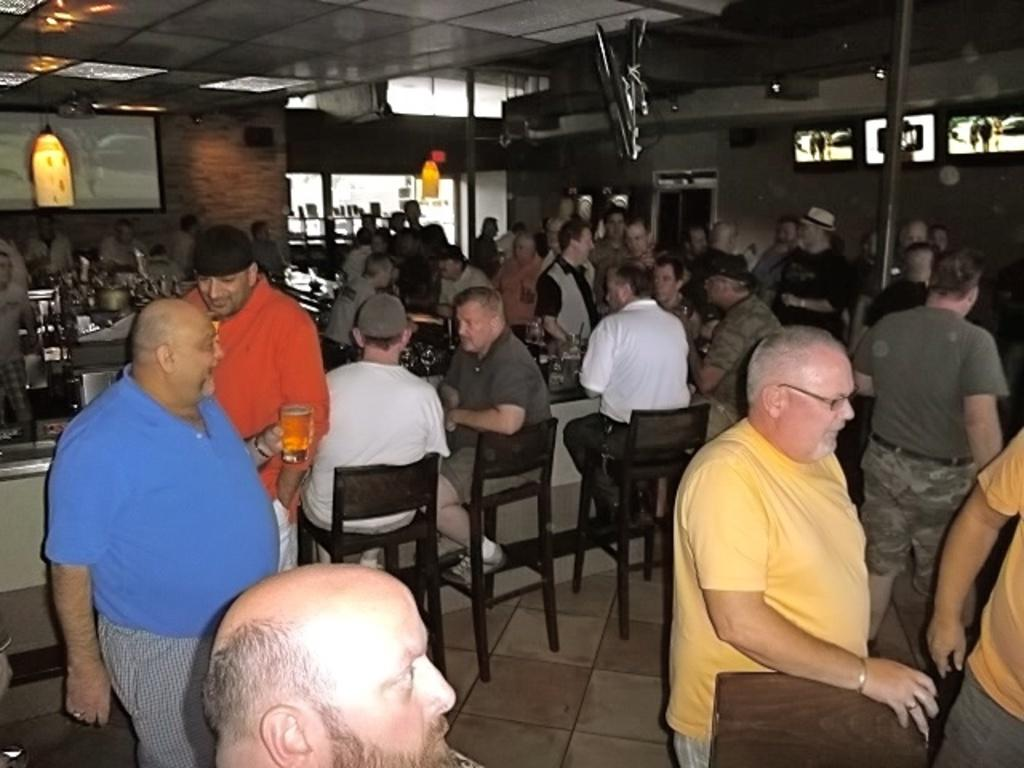How many people are in the image? There is a group of people in the image. What are some of the people doing in the image? Some people are sitting on chairs, and some people are standing on the floor. What is the purpose of the table in the image? The table's purpose is not specified in the facts, but it could be used for various activities, such as eating or working. Is there a fight happening between the people in the image? There is no indication of a fight in the image; the people are either sitting or standing. What type of cabbage is being served on the table in the image? There is no cabbage present in the image; the table's purpose is not specified. 